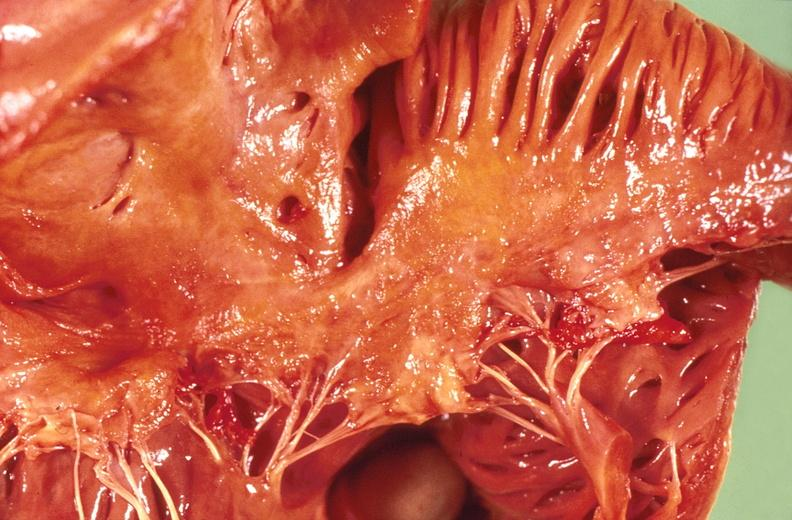what does this image show?
Answer the question using a single word or phrase. Amyloidosis 